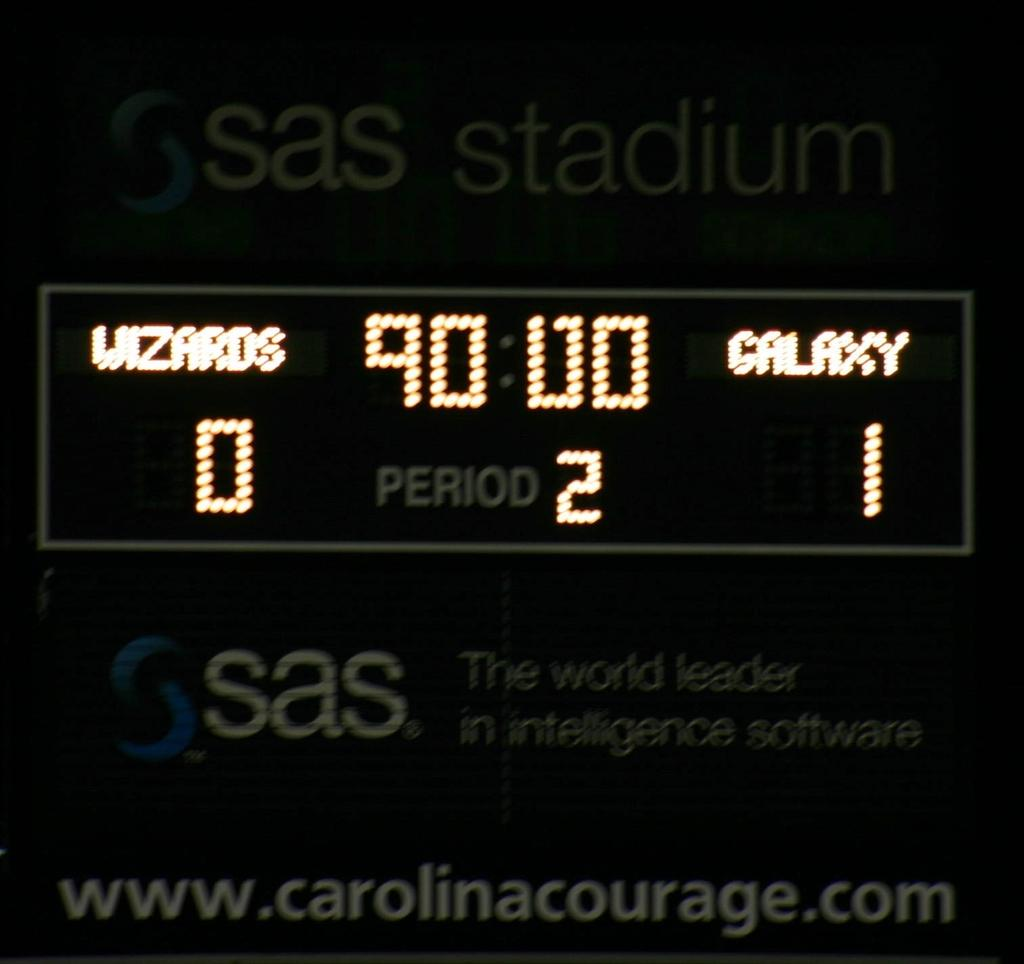<image>
Offer a succinct explanation of the picture presented. The scoreboard at Sas Stadium shows the score is Galaxy 1, Wizzards 0 and they are in the second period. 